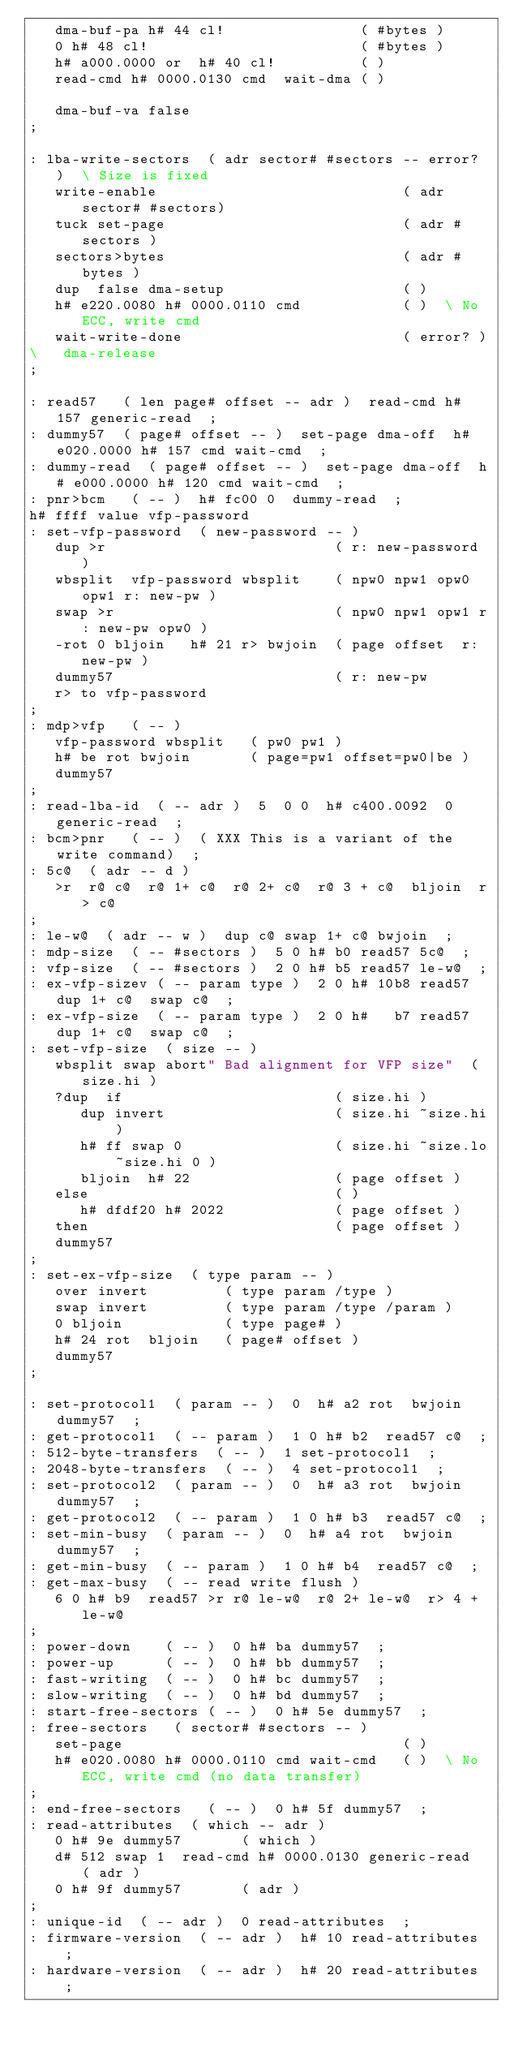Convert code to text. <code><loc_0><loc_0><loc_500><loc_500><_Forth_>   dma-buf-pa h# 44 cl!                ( #bytes )
   0 h# 48 cl!                         ( #bytes )
   h# a000.0000 or  h# 40 cl!          ( )
   read-cmd h# 0000.0130 cmd  wait-dma ( )

   dma-buf-va false
;

: lba-write-sectors  ( adr sector# #sectors -- error? )  \ Size is fixed
   write-enable                             ( adr sector# #sectors)
   tuck set-page                            ( adr #sectors )
   sectors>bytes                            ( adr #bytes )
   dup  false dma-setup                     ( )
   h# e220.0080 h# 0000.0110 cmd            ( )  \ No ECC, write cmd
   wait-write-done                          ( error? )
\   dma-release
;

: read57   ( len page# offset -- adr )  read-cmd h# 157 generic-read  ;
: dummy57  ( page# offset -- )  set-page dma-off  h# e020.0000 h# 157 cmd wait-cmd  ;
: dummy-read  ( page# offset -- )  set-page dma-off  h# e000.0000 h# 120 cmd wait-cmd  ;
: pnr>bcm   ( -- )  h# fc00 0  dummy-read  ;
h# ffff value vfp-password
: set-vfp-password  ( new-password -- )
   dup >r                           ( r: new-password )
   wbsplit  vfp-password wbsplit    ( npw0 npw1 opw0 opw1 r: new-pw )
   swap >r                          ( npw0 npw1 opw1 r: new-pw opw0 )
   -rot 0 bljoin   h# 21 r> bwjoin  ( page offset  r: new-pw )
   dummy57                          ( r: new-pw
   r> to vfp-password
;
: mdp>vfp   ( -- )
   vfp-password wbsplit   ( pw0 pw1 )
   h# be rot bwjoin       ( page=pw1 offset=pw0|be )
   dummy57
;
: read-lba-id  ( -- adr )  5  0 0  h# c400.0092  0  generic-read  ;
: bcm>pnr   ( -- )  ( XXX This is a variant of the write command)  ;
: 5c@  ( adr -- d )
   >r  r@ c@  r@ 1+ c@  r@ 2+ c@  r@ 3 + c@  bljoin  r> c@
;
: le-w@  ( adr -- w )  dup c@ swap 1+ c@ bwjoin  ;
: mdp-size  ( -- #sectors )  5 0 h# b0 read57 5c@  ;
: vfp-size  ( -- #sectors )  2 0 h# b5 read57 le-w@  ;
: ex-vfp-sizev ( -- param type )  2 0 h# 10b8 read57 dup 1+ c@  swap c@  ;
: ex-vfp-size  ( -- param type )  2 0 h#   b7 read57 dup 1+ c@  swap c@  ;
: set-vfp-size  ( size -- )
   wbsplit swap abort" Bad alignment for VFP size"  ( size.hi )
   ?dup  if                         ( size.hi )
      dup invert                    ( size.hi ~size.hi )
      h# ff swap 0                  ( size.hi ~size.lo ~size.hi 0 )
      bljoin  h# 22                 ( page offset )
   else                             ( )
      h# dfdf20 h# 2022             ( page offset )
   then                             ( page offset )
   dummy57
;
: set-ex-vfp-size  ( type param -- )
   over invert         ( type param /type )
   swap invert         ( type param /type /param )
   0 bljoin            ( type page# )
   h# 24 rot  bljoin   ( page# offset )
   dummy57
;

: set-protocol1  ( param -- )  0  h# a2 rot  bwjoin  dummy57  ;
: get-protocol1  ( -- param )  1 0 h# b2  read57 c@  ;
: 512-byte-transfers  ( -- )  1 set-protocol1  ;
: 2048-byte-transfers  ( -- )  4 set-protocol1  ;
: set-protocol2  ( param -- )  0  h# a3 rot  bwjoin  dummy57  ;
: get-protocol2  ( -- param )  1 0 h# b3  read57 c@  ;
: set-min-busy  ( param -- )  0  h# a4 rot  bwjoin  dummy57  ;
: get-min-busy  ( -- param )  1 0 h# b4  read57 c@  ;
: get-max-busy  ( -- read write flush )
   6 0 h# b9  read57 >r r@ le-w@  r@ 2+ le-w@  r> 4 + le-w@
;
: power-down    ( -- )  0 h# ba dummy57  ;
: power-up      ( -- )  0 h# bb dummy57  ;
: fast-writing  ( -- )  0 h# bc dummy57  ;
: slow-writing  ( -- )  0 h# bd dummy57  ;
: start-free-sectors ( -- )  0 h# 5e dummy57  ;
: free-sectors   ( sector# #sectors -- )
   set-page                                 ( )
   h# e020.0080 h# 0000.0110 cmd wait-cmd   ( )  \ No ECC, write cmd (no data transfer)
;
: end-free-sectors   ( -- )  0 h# 5f dummy57  ;
: read-attributes  ( which -- adr )
   0 h# 9e dummy57       ( which )
   d# 512 swap 1  read-cmd h# 0000.0130 generic-read  ( adr )
   0 h# 9f dummy57       ( adr )
;
: unique-id  ( -- adr )  0 read-attributes  ;
: firmware-version  ( -- adr )  h# 10 read-attributes  ;
: hardware-version  ( -- adr )  h# 20 read-attributes  ;</code> 